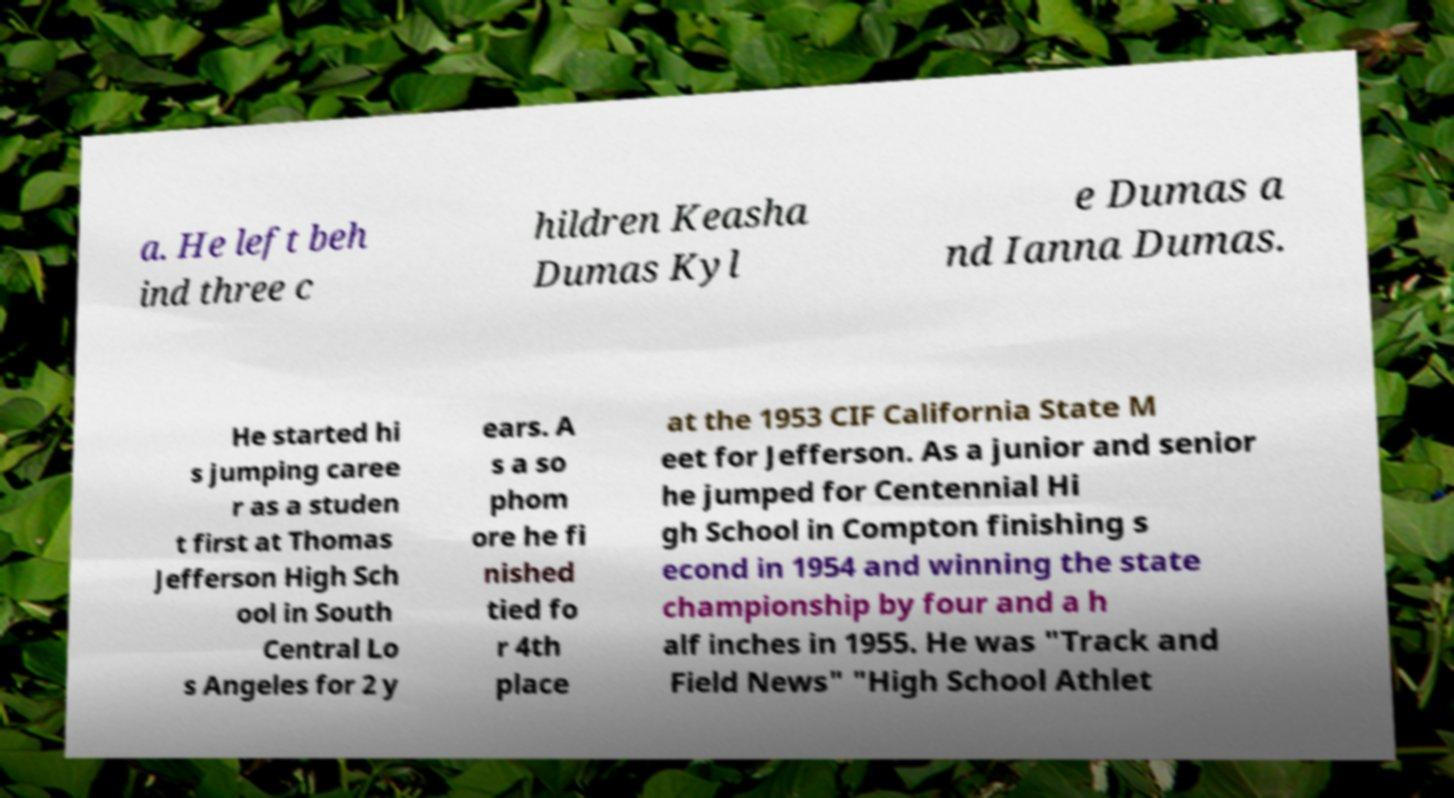For documentation purposes, I need the text within this image transcribed. Could you provide that? a. He left beh ind three c hildren Keasha Dumas Kyl e Dumas a nd Ianna Dumas. He started hi s jumping caree r as a studen t first at Thomas Jefferson High Sch ool in South Central Lo s Angeles for 2 y ears. A s a so phom ore he fi nished tied fo r 4th place at the 1953 CIF California State M eet for Jefferson. As a junior and senior he jumped for Centennial Hi gh School in Compton finishing s econd in 1954 and winning the state championship by four and a h alf inches in 1955. He was "Track and Field News" "High School Athlet 